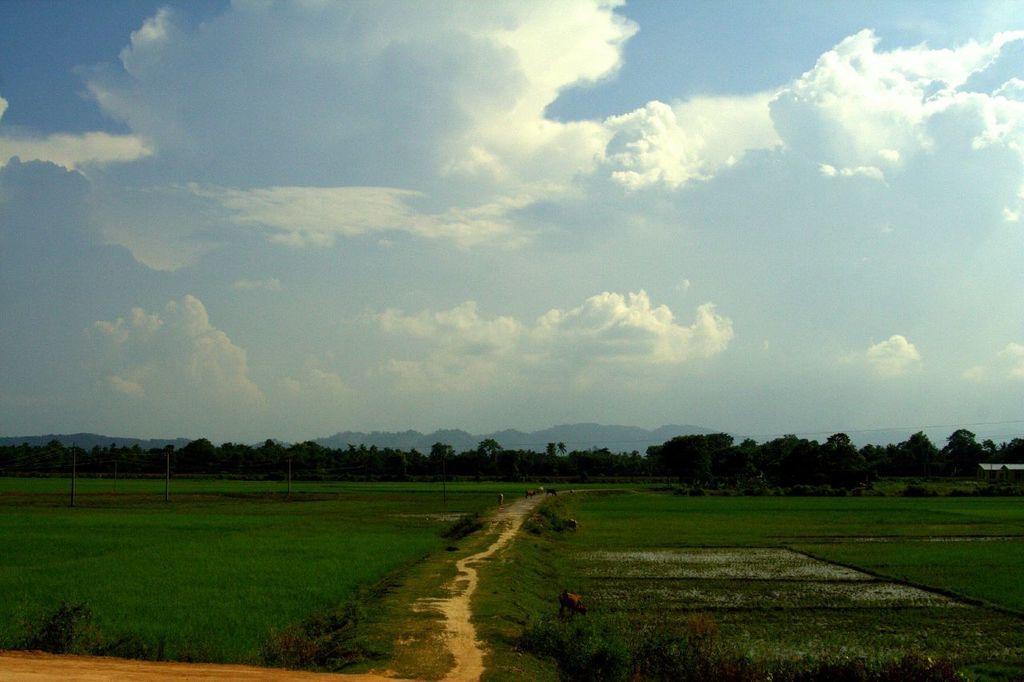Describe this image in one or two sentences. In this image I can see an open grass ground and on it I can see number of animals. In the background I can see number of poles, number of trees, clouds and the sky. I can also see a path in the centre. 